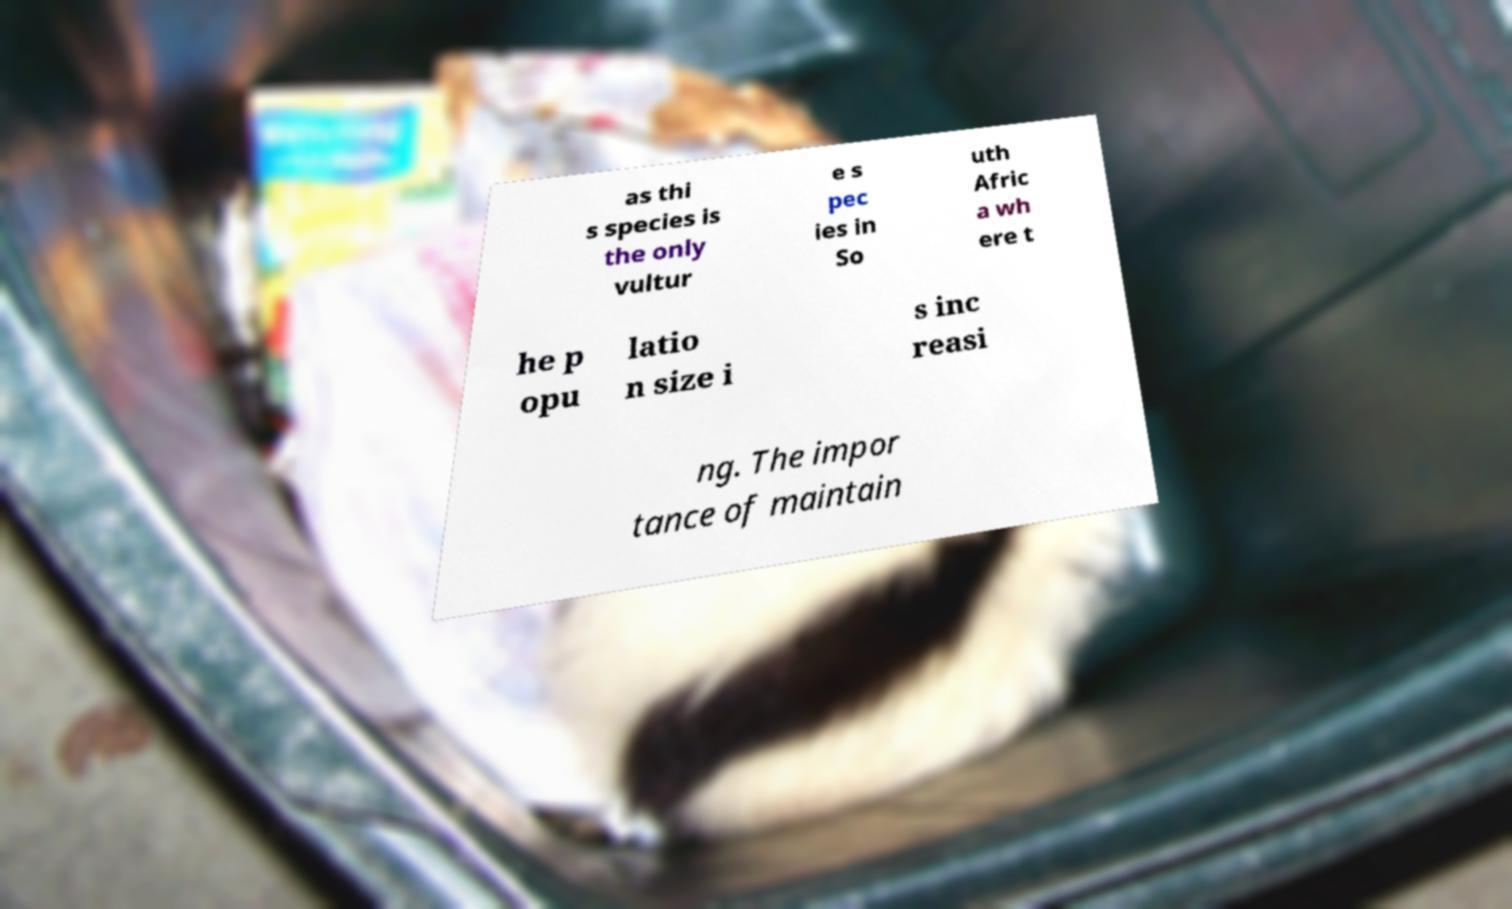Can you read and provide the text displayed in the image?This photo seems to have some interesting text. Can you extract and type it out for me? as thi s species is the only vultur e s pec ies in So uth Afric a wh ere t he p opu latio n size i s inc reasi ng. The impor tance of maintain 